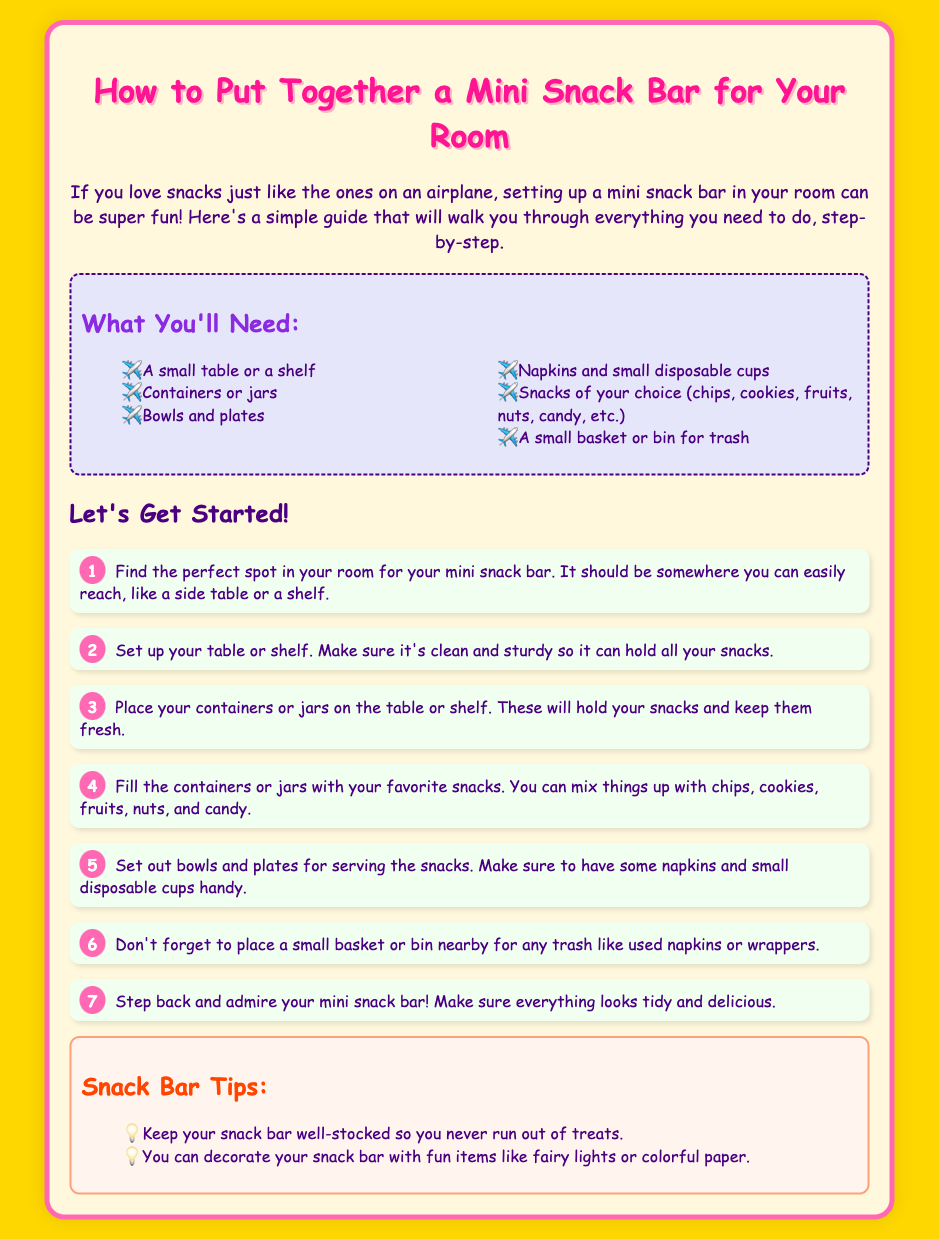What is the title of the document? The title is found in the <title> tag, which specifies the main subject of the content, focusing on assembling a mini snack bar.
Answer: Mini Snack Bar Assembly Instructions How many materials do you need? The list of materials is detailed in the materials section. Counting them gives us the total number of required materials.
Answer: 6 What should you fill the containers or jars with? This information is presented in step 4, which describes the contents of the containers or jars for the snack bar.
Answer: Snacks What is the color of the background? The background color is indicated in the CSS section and refers to the document's visual styling.
Answer: Yellow How should the table or shelf be? This is described in step 2, which details the requirements for setting up the table or shelf for the snack bar.
Answer: Clean and sturdy What is one way to decorate the snack bar? The tips section provides ideas for decorating, emphasizing fun items that can enhance the appearance of the snack bar.
Answer: Fairy lights How many steps are there to set up the snack bar? By counting the steps listed in the instructions section, we can determine the total number of steps involved in the assembly process.
Answer: 7 What color is used for the headers? The document specifies the color codes in CSS, so the headers can be identified by examining the styles applied.
Answer: Pink 